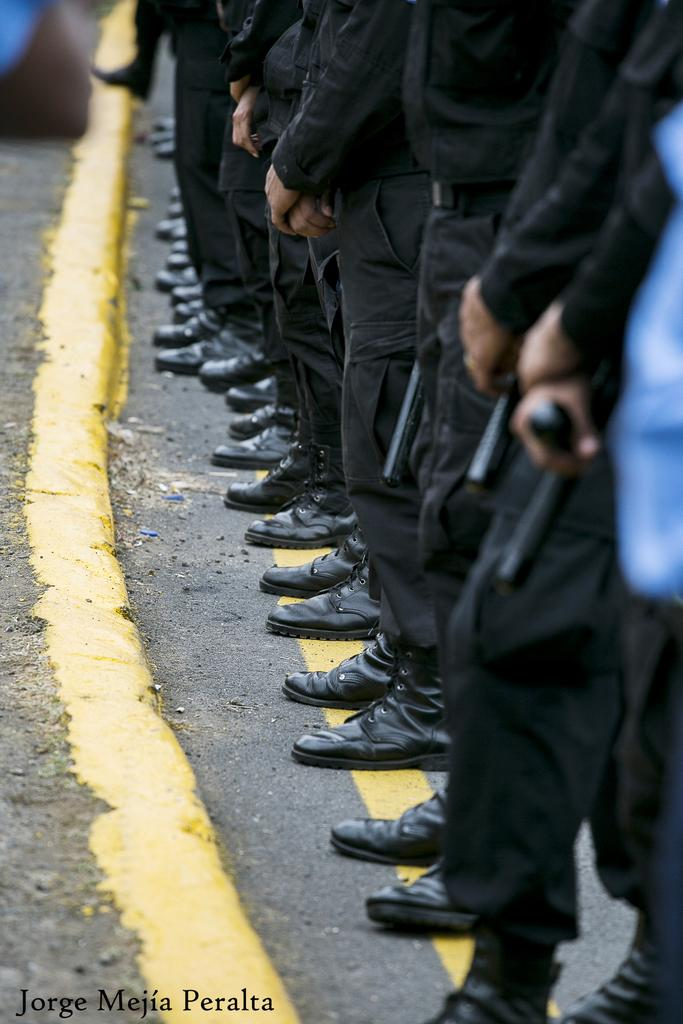What are the people in the image doing? The people in the image are standing on the road. Are there any specific objects or items that the people are holding? Yes, some people are holding guns in the image. Can you describe the object on the right side of the image? Unfortunately, the provided facts do not give any information about the object on the right side of the image. How much chalk is being used by the people in the image? There is no mention of chalk in the image, so it cannot be determined how much chalk is being used. 